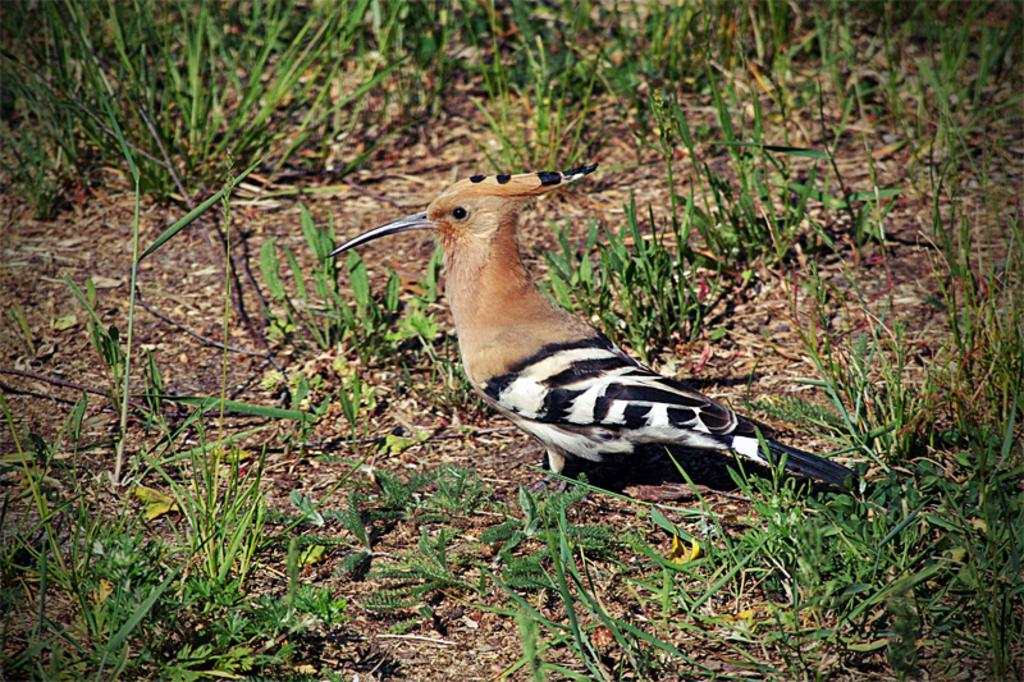What type of animal can be seen in the image? There is a bird in the image. What is the ground covered with in the image? There is grass on the ground in the image. What holiday is being celebrated in the image? There is no indication of a holiday being celebrated in the image. How many ducks are present in the image? There are no ducks present in the image; it features a bird. 